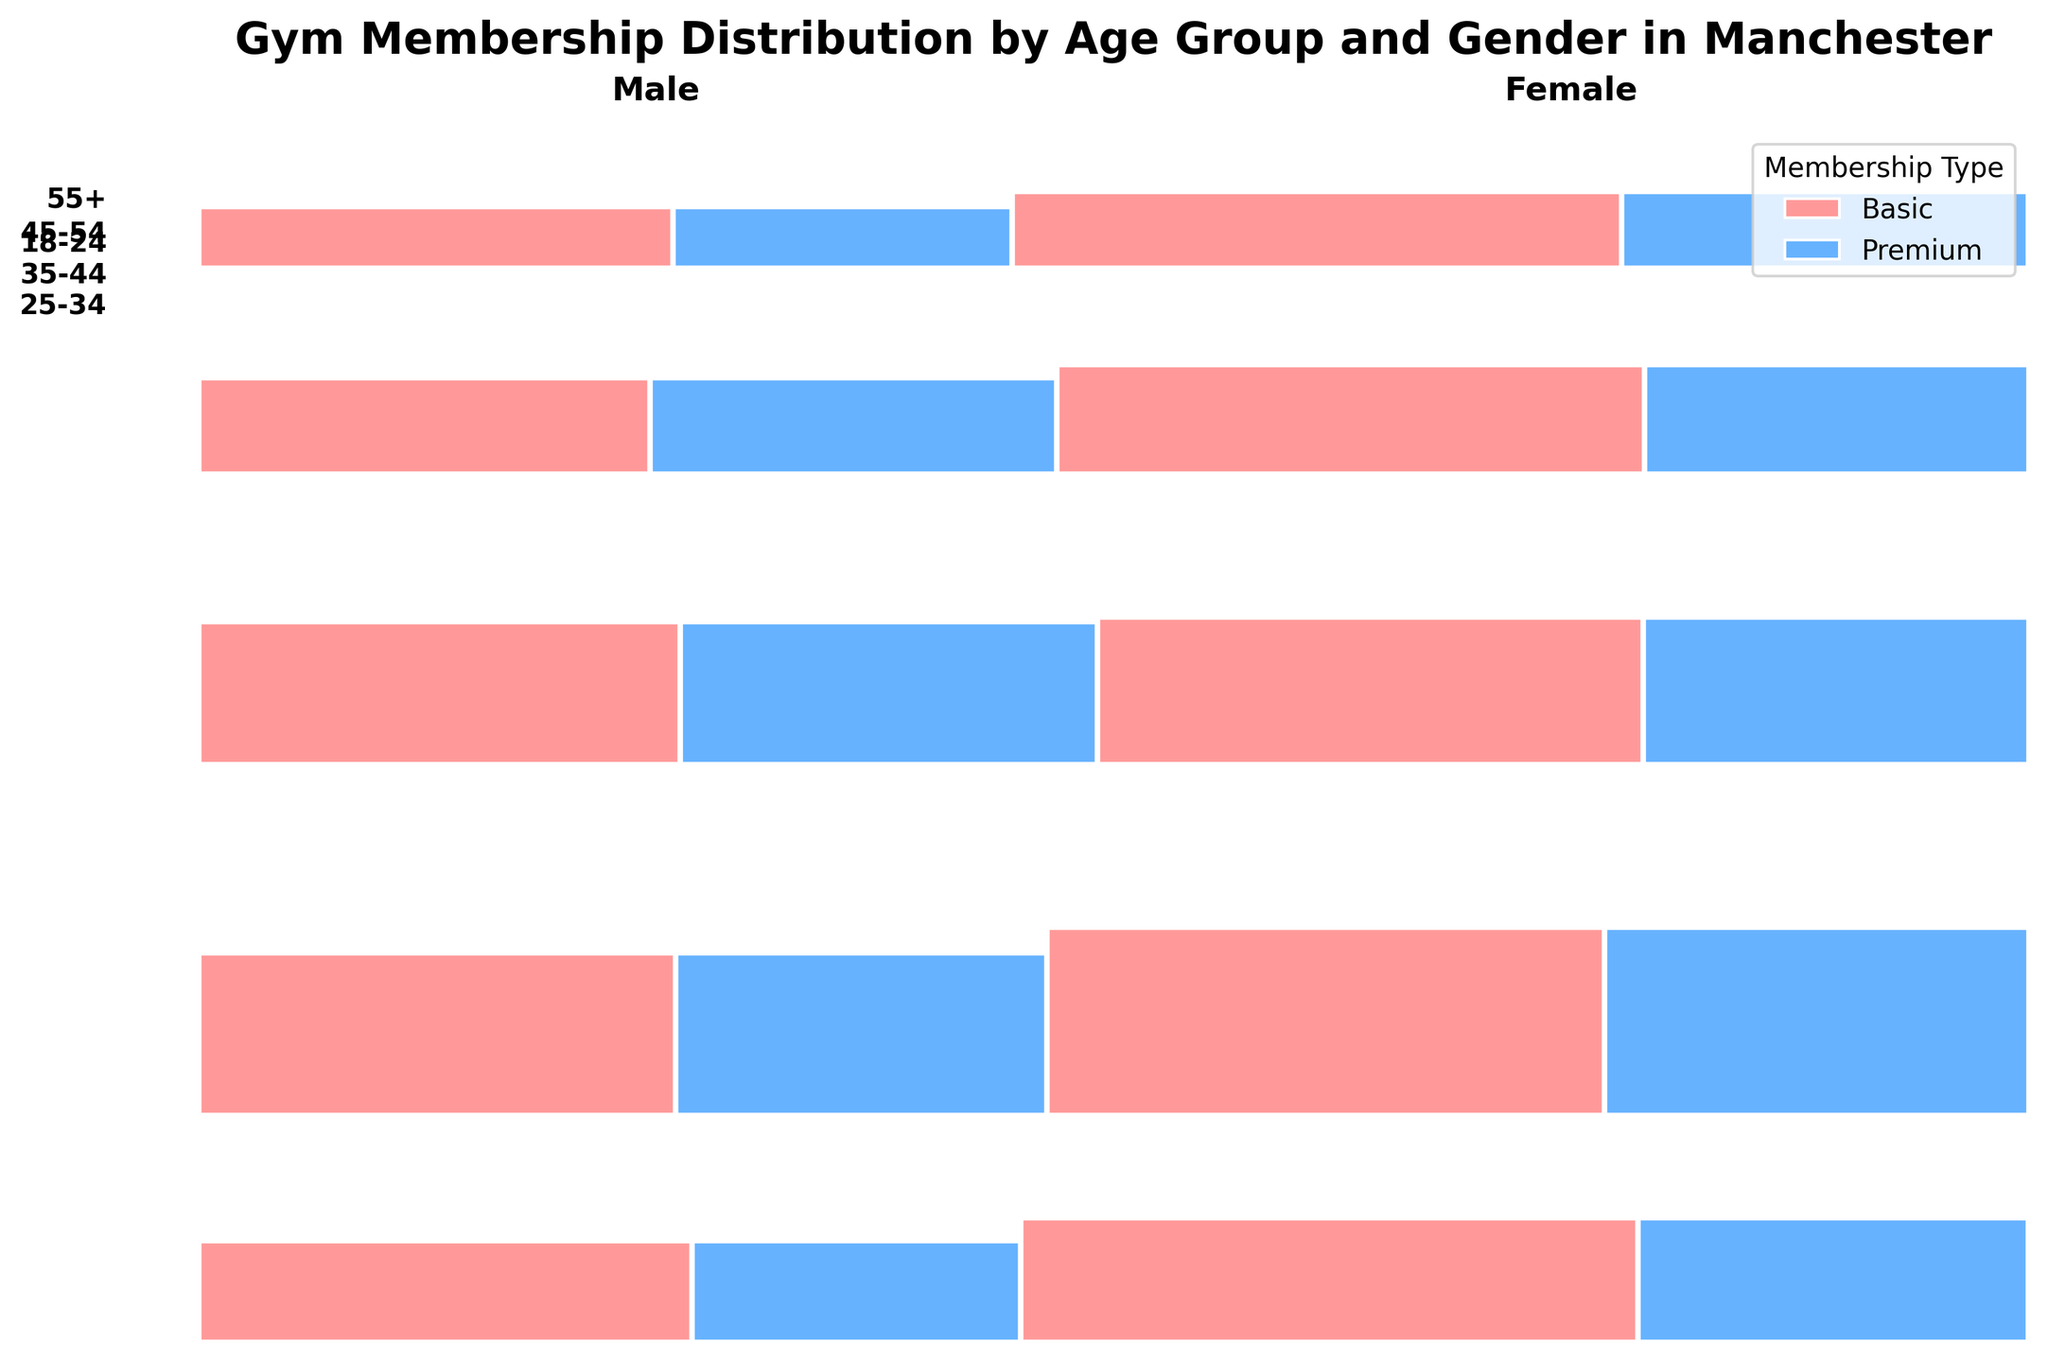What's the title of the figure? The title is usually displayed at the top of the figure. In this plot, the title is clearly shown above the data visualization.
Answer: Gym Membership Distribution by Age Group and Gender in Manchester What are the colors used to represent the membership types? By looking at the legend in the top-right corner of the mosaic plot, the colors representing Basic and Premium membership types can be identified.
Answer: Red and Blue Which age group has the largest overall membership count? The largest age group is represented by the widest horizontal section in the plot, which indicates the highest proportion of overall membership.
Answer: 25-34 In the 35-44 age group, which gender has more Premium memberships? By comparing the width of the sections for Premium memberships for both males and females within the 35-44 age group, it can be determined which gender has more Premium memberships.
Answer: Male Which age group has the smallest proportion of Basic memberships for females? By examining the vertical sections for Basic memberships for females across all age groups, the narrowest section would indicate the smallest proportion.
Answer: 55+ Compare the proportion of Basic memberships for males in the 18-24 age group with the 55+ age group. Which is higher? By comparing the widths of the Basic membership sections for males in the 18-24 and 55+ age groups, the relative proportions can be assessed.
Answer: 18-24 In the 25-34 age group, how does the proportion of Basic memberships compare between males and females? By comparing the widths of the Basic membership sections within the 25-34 age group for both genders, it can be determined which gender has a higher proportion of Basic memberships.
Answer: Females have a higher proportion Among all age groups, which gender tends to have a higher proportion of Premium memberships? By observing the widths of the Premium membership sections for both genders across all age groups, it can be assessed which gender generally has a higher proportion.
Answer: Males Does the 45-54 age group's overall section take up more or less horizontal space compared to the 35-44 age group? The overall width of each age group section can be compared to see if 45-54 takes up more or less horizontal space than 35-44.
Answer: Less Which age and gender group has the smallest Premium membership proportion? By identifying the narrowest segment for Premium memberships across all age groups and genders, the smallest proportion can be found.
Answer: 55+ Female 